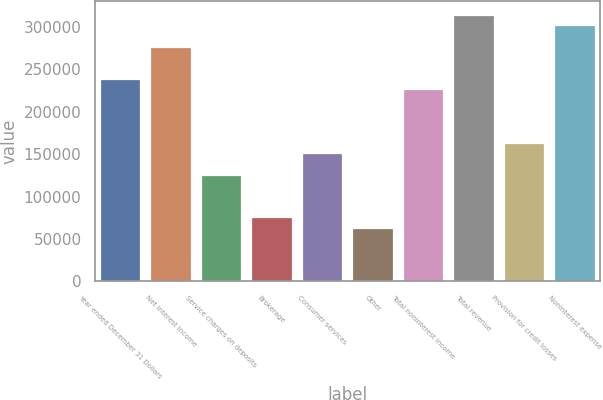Convert chart to OTSL. <chart><loc_0><loc_0><loc_500><loc_500><bar_chart><fcel>Year ended December 31 Dollars<fcel>Net interest income<fcel>Service charges on deposits<fcel>Brokerage<fcel>Consumer services<fcel>Other<fcel>Total noninterest income<fcel>Total revenue<fcel>Provision for credit losses<fcel>Noninterest expense<nl><fcel>238642<fcel>276322<fcel>125601<fcel>75360.7<fcel>150721<fcel>62800.6<fcel>226082<fcel>314002<fcel>163281<fcel>301442<nl></chart> 